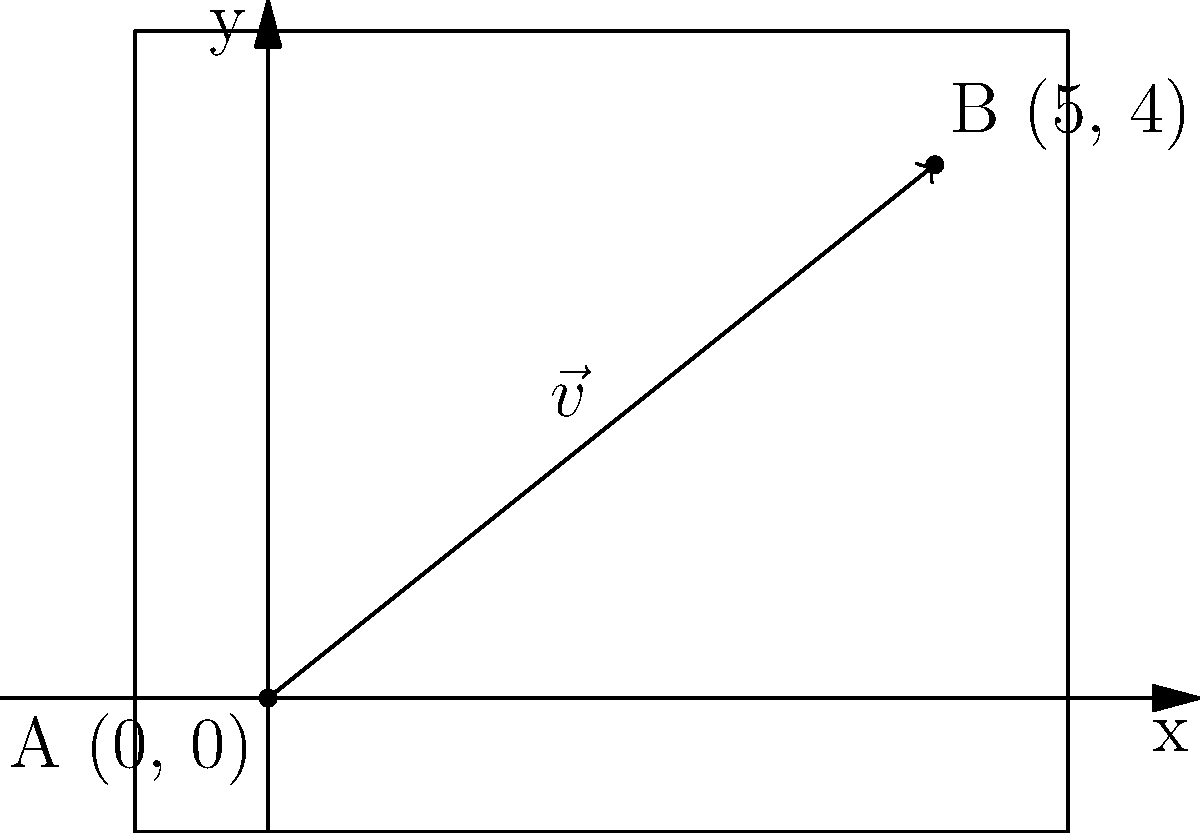In your latest spy thriller fanfiction, you need to calculate the distance between two secret hideouts. Hideout A is located at the origin (0, 0), and Hideout B is at coordinates (5, 4). Given that the position vector $\vec{v}$ from A to B is represented as $\vec{v} = 5\hat{i} + 4\hat{j}$, what is the distance between the two hideouts? To find the distance between the two hideouts, we need to calculate the magnitude of the position vector $\vec{v}$. Here's how we can do it step-by-step:

1) The position vector $\vec{v}$ is given as $\vec{v} = 5\hat{i} + 4\hat{j}$.

2) To find the magnitude of this vector, we use the Pythagorean theorem:
   $$|\vec{v}| = \sqrt{x^2 + y^2}$$
   where $x$ and $y$ are the components of the vector.

3) Substituting the values:
   $$|\vec{v}| = \sqrt{5^2 + 4^2}$$

4) Simplify:
   $$|\vec{v}| = \sqrt{25 + 16}$$
   $$|\vec{v}| = \sqrt{41}$$

5) The square root of 41 is approximately 6.40312423743285.

Therefore, the distance between the two hideouts is $\sqrt{41}$ units, or approximately 6.40 units when rounded to two decimal places.
Answer: $\sqrt{41}$ units (≈ 6.40 units) 